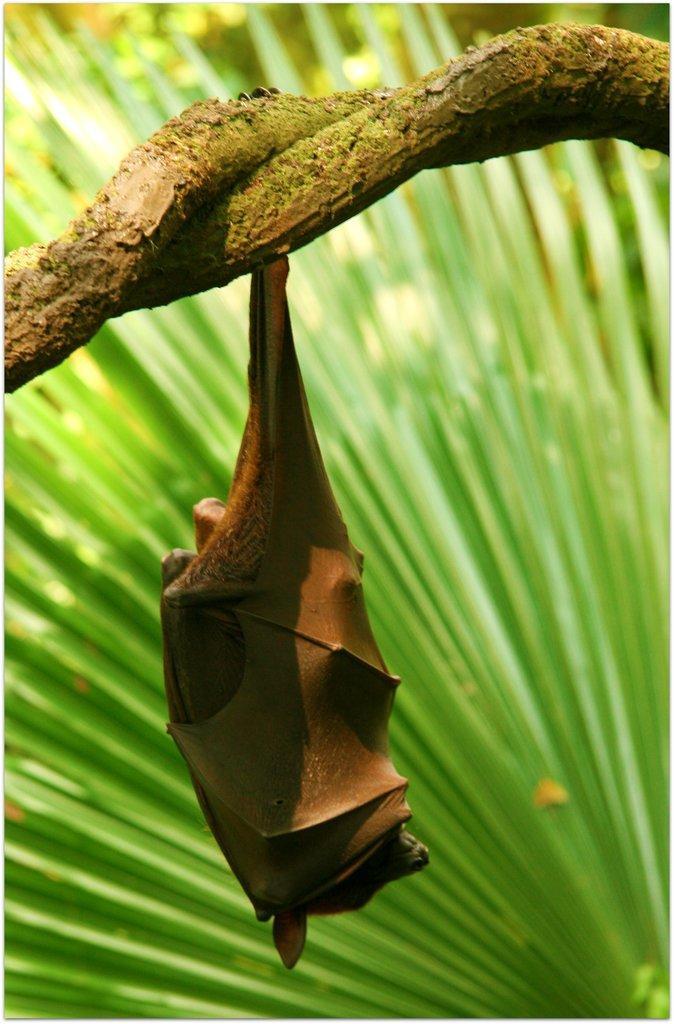In one or two sentences, can you explain what this image depicts? In this image we can see a bat is hanging to a branch. In the background we can see greenery. 